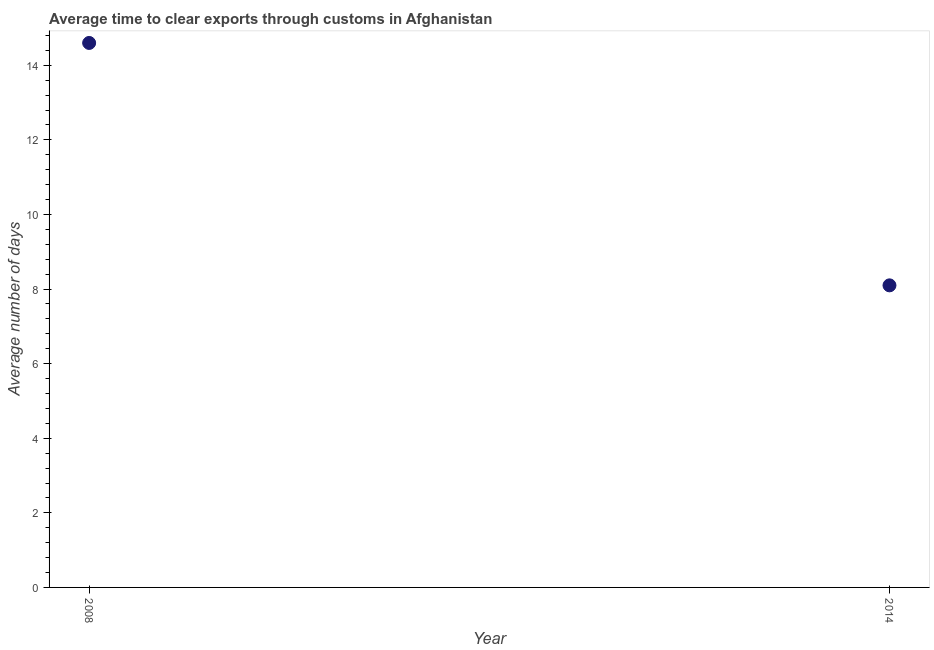What is the time to clear exports through customs in 2008?
Keep it short and to the point. 14.6. Across all years, what is the maximum time to clear exports through customs?
Provide a short and direct response. 14.6. What is the sum of the time to clear exports through customs?
Make the answer very short. 22.7. What is the average time to clear exports through customs per year?
Offer a terse response. 11.35. What is the median time to clear exports through customs?
Keep it short and to the point. 11.35. In how many years, is the time to clear exports through customs greater than 2 days?
Make the answer very short. 2. What is the ratio of the time to clear exports through customs in 2008 to that in 2014?
Keep it short and to the point. 1.8. Does the time to clear exports through customs monotonically increase over the years?
Your answer should be very brief. No. Are the values on the major ticks of Y-axis written in scientific E-notation?
Provide a succinct answer. No. Does the graph contain any zero values?
Offer a very short reply. No. What is the title of the graph?
Offer a very short reply. Average time to clear exports through customs in Afghanistan. What is the label or title of the Y-axis?
Keep it short and to the point. Average number of days. What is the Average number of days in 2008?
Give a very brief answer. 14.6. What is the Average number of days in 2014?
Your answer should be compact. 8.1. What is the difference between the Average number of days in 2008 and 2014?
Provide a short and direct response. 6.5. What is the ratio of the Average number of days in 2008 to that in 2014?
Keep it short and to the point. 1.8. 